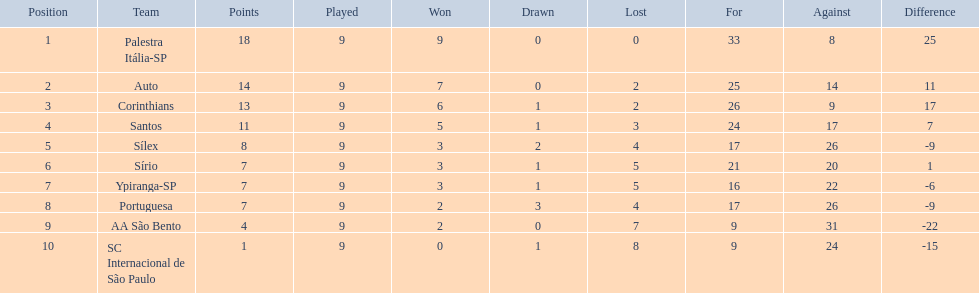Which teams are included in the list? Palestra Itália-SP, Auto, Corinthians, Santos, Sílex, Sírio, Ypiranga-SP, Portuguesa, AA São Bento, SC Internacional de São Paulo. What is the number of losses for each team? 0, 2, 2, 3, 4, 5, 5, 4, 7, 8. And, did any team manage to avoid losing a single game? Palestra Itália-SP. 